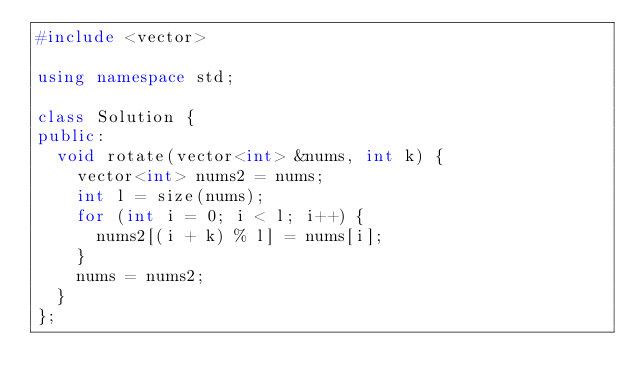<code> <loc_0><loc_0><loc_500><loc_500><_C++_>#include <vector>

using namespace std;

class Solution {
public:
  void rotate(vector<int> &nums, int k) {
    vector<int> nums2 = nums;
    int l = size(nums);
    for (int i = 0; i < l; i++) {
      nums2[(i + k) % l] = nums[i];
    }
    nums = nums2;
  }
};</code> 